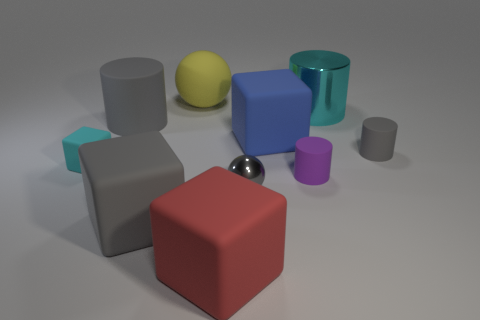Subtract all brown blocks. Subtract all red balls. How many blocks are left? 4 Subtract all blocks. How many objects are left? 6 Subtract all big brown matte cylinders. Subtract all small shiny things. How many objects are left? 9 Add 3 tiny cyan rubber blocks. How many tiny cyan rubber blocks are left? 4 Add 3 blue rubber cubes. How many blue rubber cubes exist? 4 Subtract 0 cyan balls. How many objects are left? 10 